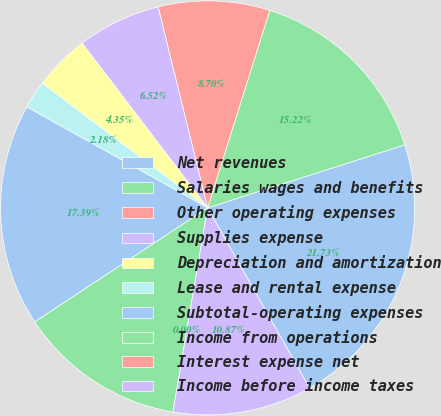Convert chart. <chart><loc_0><loc_0><loc_500><loc_500><pie_chart><fcel>Net revenues<fcel>Salaries wages and benefits<fcel>Other operating expenses<fcel>Supplies expense<fcel>Depreciation and amortization<fcel>Lease and rental expense<fcel>Subtotal-operating expenses<fcel>Income from operations<fcel>Interest expense net<fcel>Income before income taxes<nl><fcel>21.73%<fcel>15.22%<fcel>8.7%<fcel>6.52%<fcel>4.35%<fcel>2.18%<fcel>17.39%<fcel>13.04%<fcel>0.0%<fcel>10.87%<nl></chart> 